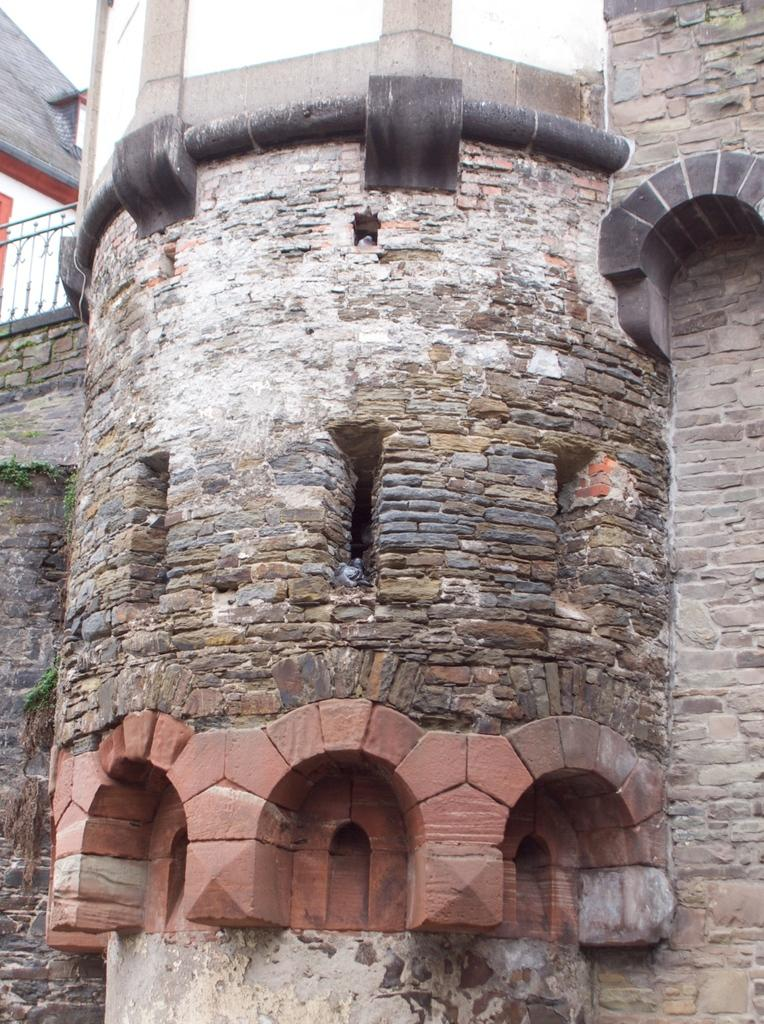What is the main structure in the center of the image? There is a fort in the center of the image. What can be seen on the left side of the image? There is a fence on the left side of the image. How many apples are on the fort in the image? There are no apples present in the image. Can you see an ant crawling on the fence in the image? There is no ant visible in the image. 